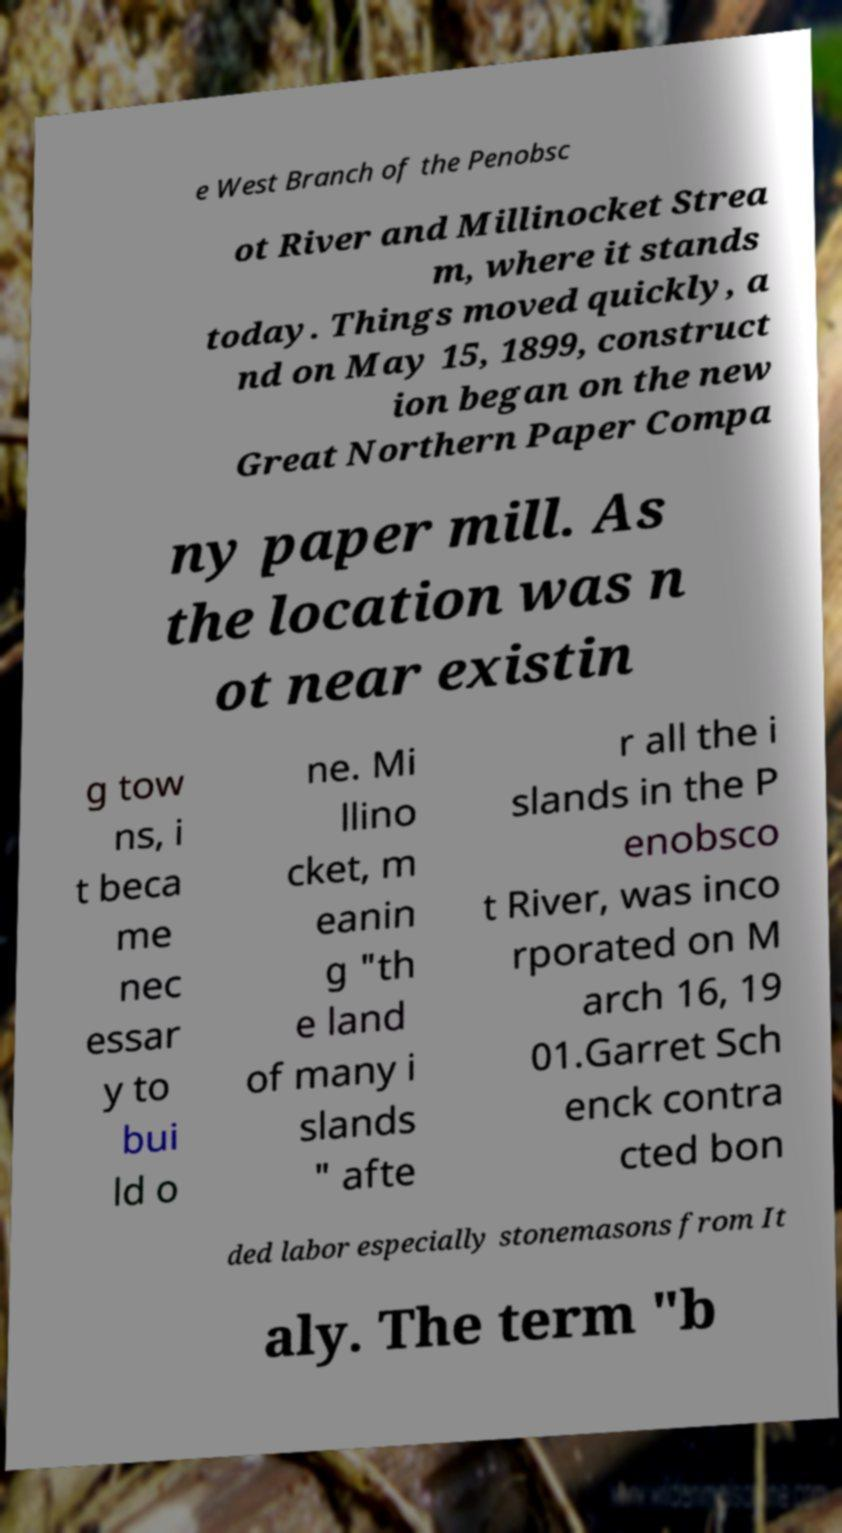Please identify and transcribe the text found in this image. e West Branch of the Penobsc ot River and Millinocket Strea m, where it stands today. Things moved quickly, a nd on May 15, 1899, construct ion began on the new Great Northern Paper Compa ny paper mill. As the location was n ot near existin g tow ns, i t beca me nec essar y to bui ld o ne. Mi llino cket, m eanin g "th e land of many i slands " afte r all the i slands in the P enobsco t River, was inco rporated on M arch 16, 19 01.Garret Sch enck contra cted bon ded labor especially stonemasons from It aly. The term "b 